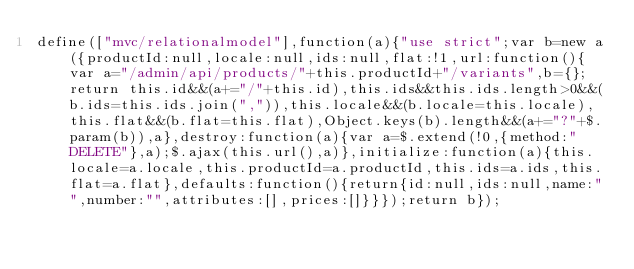Convert code to text. <code><loc_0><loc_0><loc_500><loc_500><_JavaScript_>define(["mvc/relationalmodel"],function(a){"use strict";var b=new a({productId:null,locale:null,ids:null,flat:!1,url:function(){var a="/admin/api/products/"+this.productId+"/variants",b={};return this.id&&(a+="/"+this.id),this.ids&&this.ids.length>0&&(b.ids=this.ids.join(",")),this.locale&&(b.locale=this.locale),this.flat&&(b.flat=this.flat),Object.keys(b).length&&(a+="?"+$.param(b)),a},destroy:function(a){var a=$.extend(!0,{method:"DELETE"},a);$.ajax(this.url(),a)},initialize:function(a){this.locale=a.locale,this.productId=a.productId,this.ids=a.ids,this.flat=a.flat},defaults:function(){return{id:null,ids:null,name:"",number:"",attributes:[],prices:[]}}});return b});</code> 